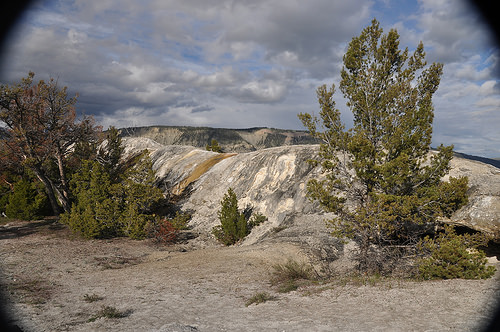<image>
Is there a tree on the rock? Yes. Looking at the image, I can see the tree is positioned on top of the rock, with the rock providing support. 